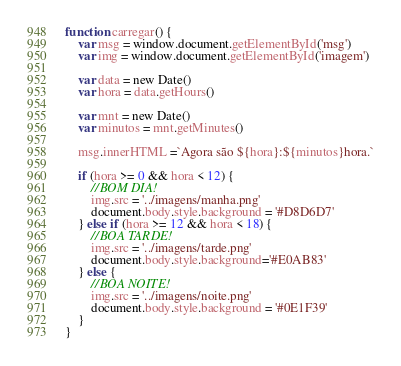Convert code to text. <code><loc_0><loc_0><loc_500><loc_500><_JavaScript_>function carregar() {
    var msg = window.document.getElementById('msg')
    var img = window.document.getElementById('imagem')
    
    var data = new Date()
    var hora = data.getHours()

    var mnt = new Date()
    var minutos = mnt.getMinutes()
    
    msg.innerHTML =`Agora são ${hora}:${minutos}hora.`

    if (hora >= 0 && hora < 12) {
        //BOM DIA!
        img.src = '../imagens/manha.png'
        document.body.style.background = '#D8D6D7'
    } else if (hora >= 12 && hora < 18) {
        //BOA TARDE!
        img.src = '../imagens/tarde.png'
        document.body.style.background='#E0AB83'
    } else {
        //BOA NOITE!
        img.src = '../imagens/noite.png'
        document.body.style.background = '#0E1F39'
    }
}</code> 